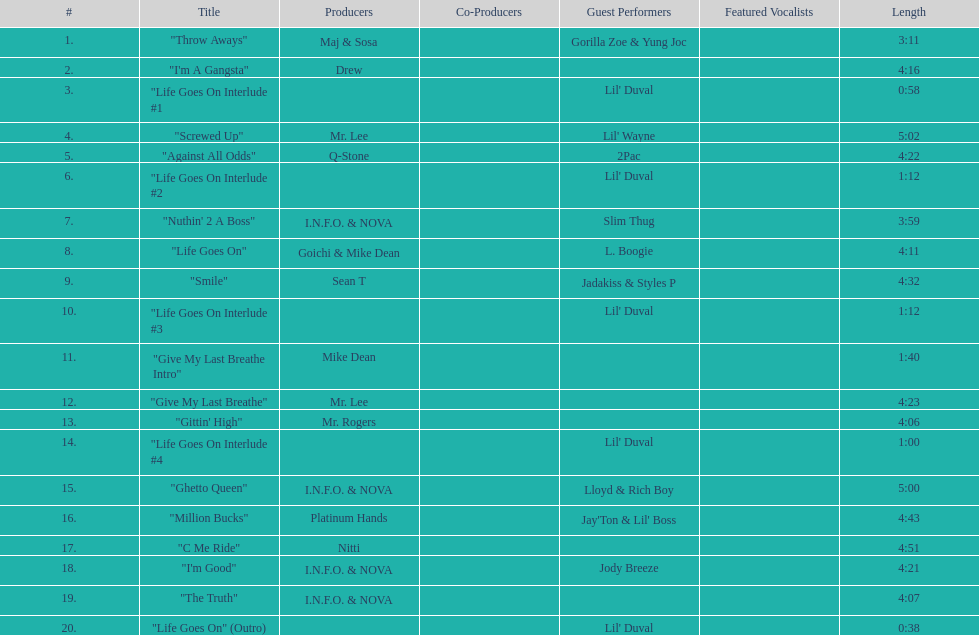What is the number of tracks featuring 2pac? 1. 